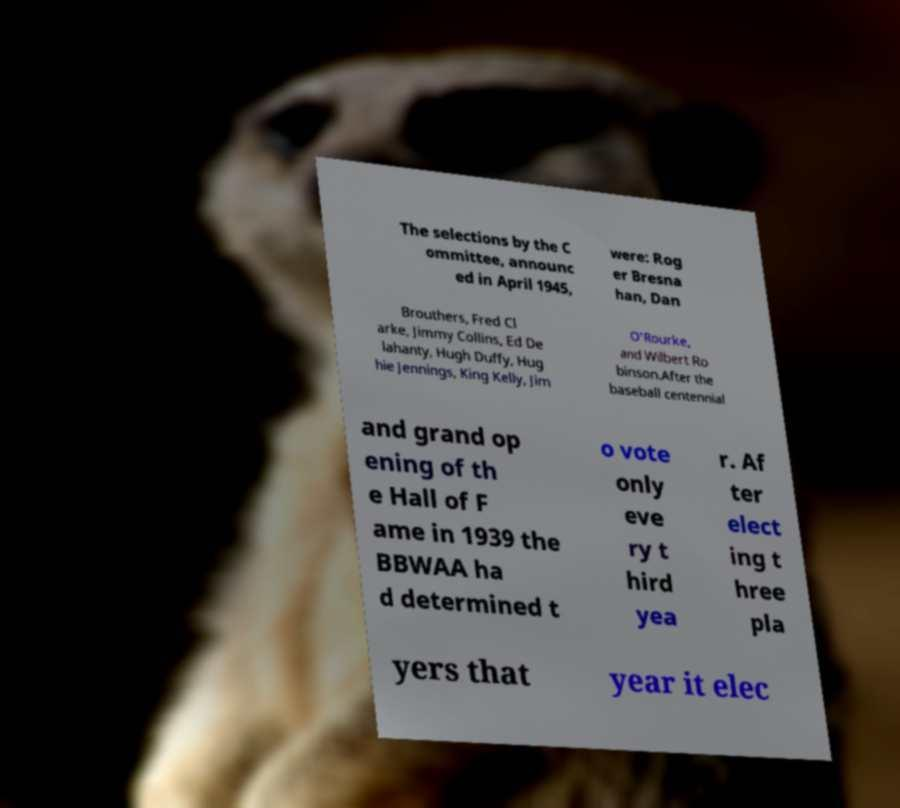Please read and relay the text visible in this image. What does it say? The selections by the C ommittee, announc ed in April 1945, were: Rog er Bresna han, Dan Brouthers, Fred Cl arke, Jimmy Collins, Ed De lahanty, Hugh Duffy, Hug hie Jennings, King Kelly, Jim O'Rourke, and Wilbert Ro binson.After the baseball centennial and grand op ening of th e Hall of F ame in 1939 the BBWAA ha d determined t o vote only eve ry t hird yea r. Af ter elect ing t hree pla yers that year it elec 